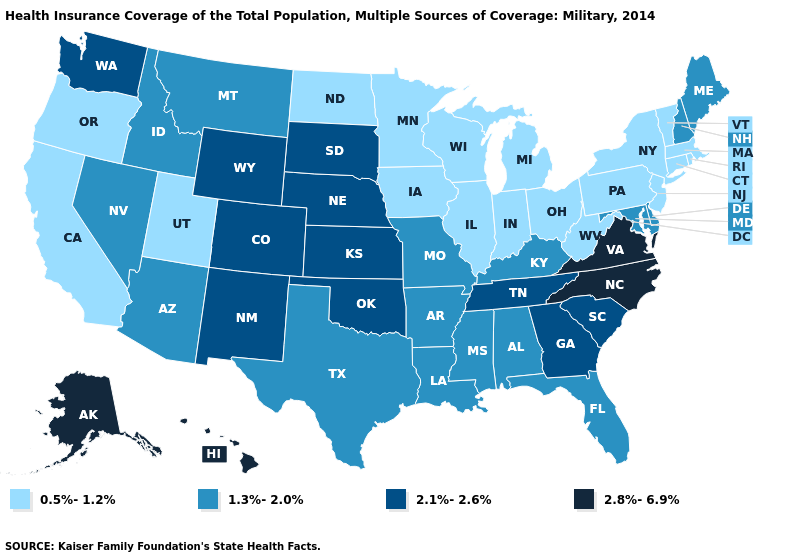Among the states that border Virginia , which have the lowest value?
Be succinct. West Virginia. What is the value of Arizona?
Keep it brief. 1.3%-2.0%. How many symbols are there in the legend?
Short answer required. 4. Does Idaho have the same value as Louisiana?
Be succinct. Yes. What is the value of Maine?
Keep it brief. 1.3%-2.0%. Does Louisiana have a lower value than Florida?
Answer briefly. No. Name the states that have a value in the range 0.5%-1.2%?
Answer briefly. California, Connecticut, Illinois, Indiana, Iowa, Massachusetts, Michigan, Minnesota, New Jersey, New York, North Dakota, Ohio, Oregon, Pennsylvania, Rhode Island, Utah, Vermont, West Virginia, Wisconsin. Does Colorado have the highest value in the USA?
Answer briefly. No. Is the legend a continuous bar?
Keep it brief. No. What is the lowest value in states that border Georgia?
Be succinct. 1.3%-2.0%. What is the value of North Dakota?
Short answer required. 0.5%-1.2%. Among the states that border Oklahoma , which have the lowest value?
Keep it brief. Arkansas, Missouri, Texas. Is the legend a continuous bar?
Give a very brief answer. No. Among the states that border Georgia , which have the lowest value?
Write a very short answer. Alabama, Florida. Name the states that have a value in the range 0.5%-1.2%?
Quick response, please. California, Connecticut, Illinois, Indiana, Iowa, Massachusetts, Michigan, Minnesota, New Jersey, New York, North Dakota, Ohio, Oregon, Pennsylvania, Rhode Island, Utah, Vermont, West Virginia, Wisconsin. 